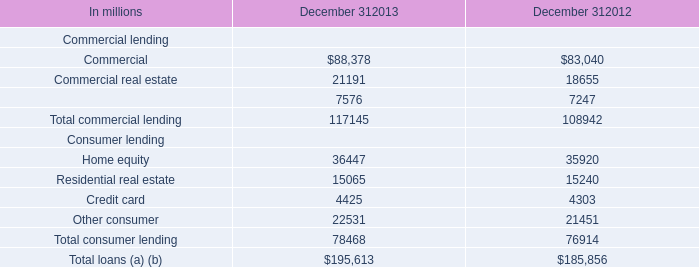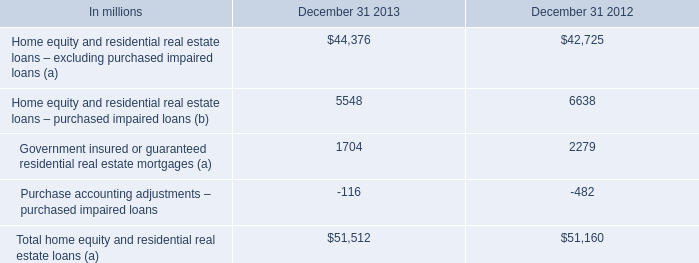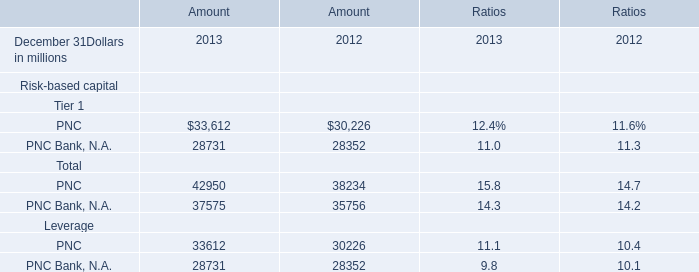What is the total amount of Home equity Consumer lending of December 312013, PNC Bank, N.A. of Amount 2012, and Total consumer lending Consumer lending of December 312012 ? 
Computations: ((36447.0 + 28352.0) + 76914.0)
Answer: 141713.0. 